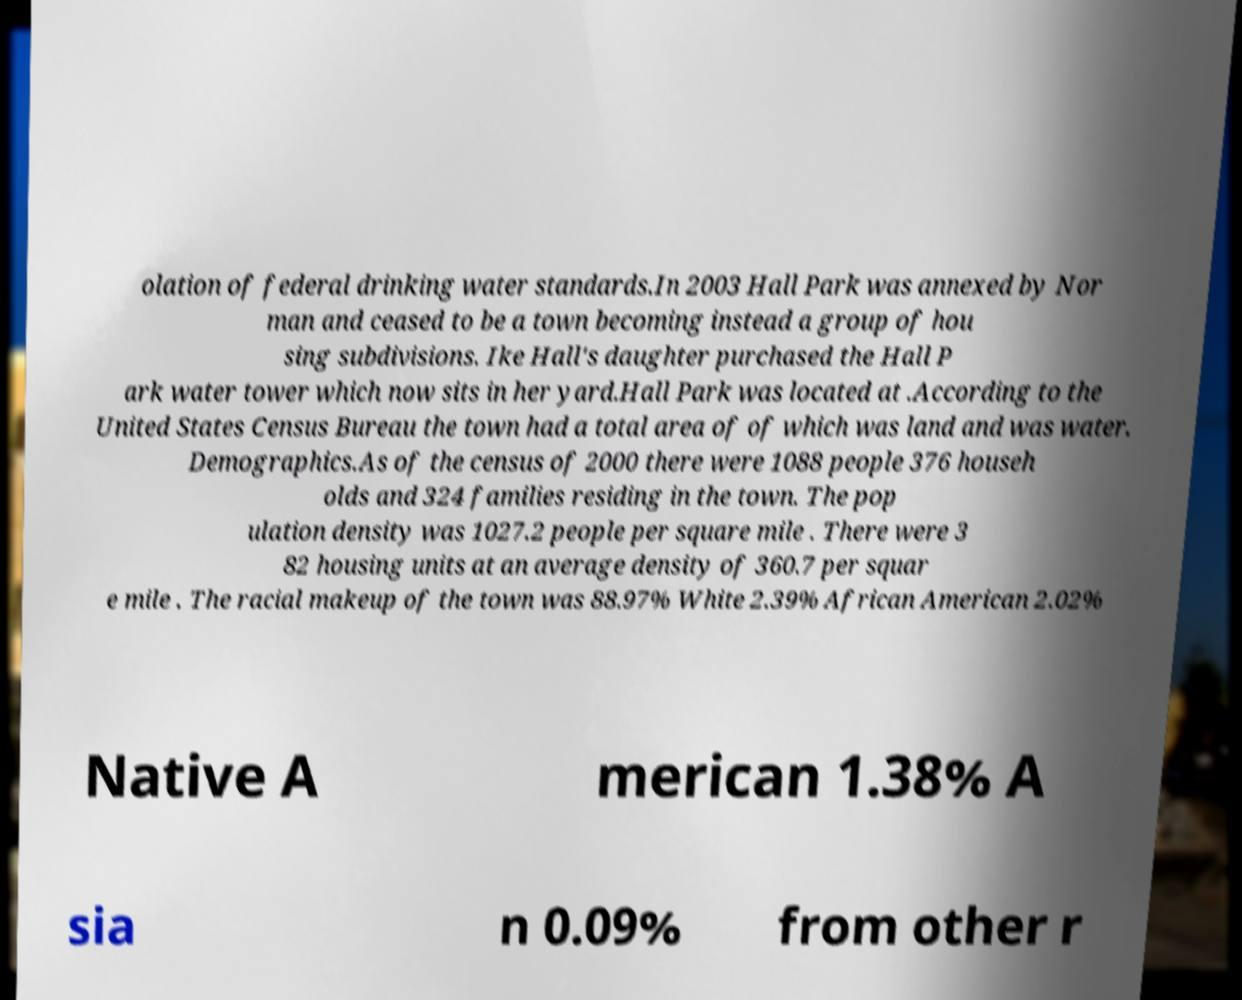What messages or text are displayed in this image? I need them in a readable, typed format. olation of federal drinking water standards.In 2003 Hall Park was annexed by Nor man and ceased to be a town becoming instead a group of hou sing subdivisions. Ike Hall's daughter purchased the Hall P ark water tower which now sits in her yard.Hall Park was located at .According to the United States Census Bureau the town had a total area of of which was land and was water. Demographics.As of the census of 2000 there were 1088 people 376 househ olds and 324 families residing in the town. The pop ulation density was 1027.2 people per square mile . There were 3 82 housing units at an average density of 360.7 per squar e mile . The racial makeup of the town was 88.97% White 2.39% African American 2.02% Native A merican 1.38% A sia n 0.09% from other r 